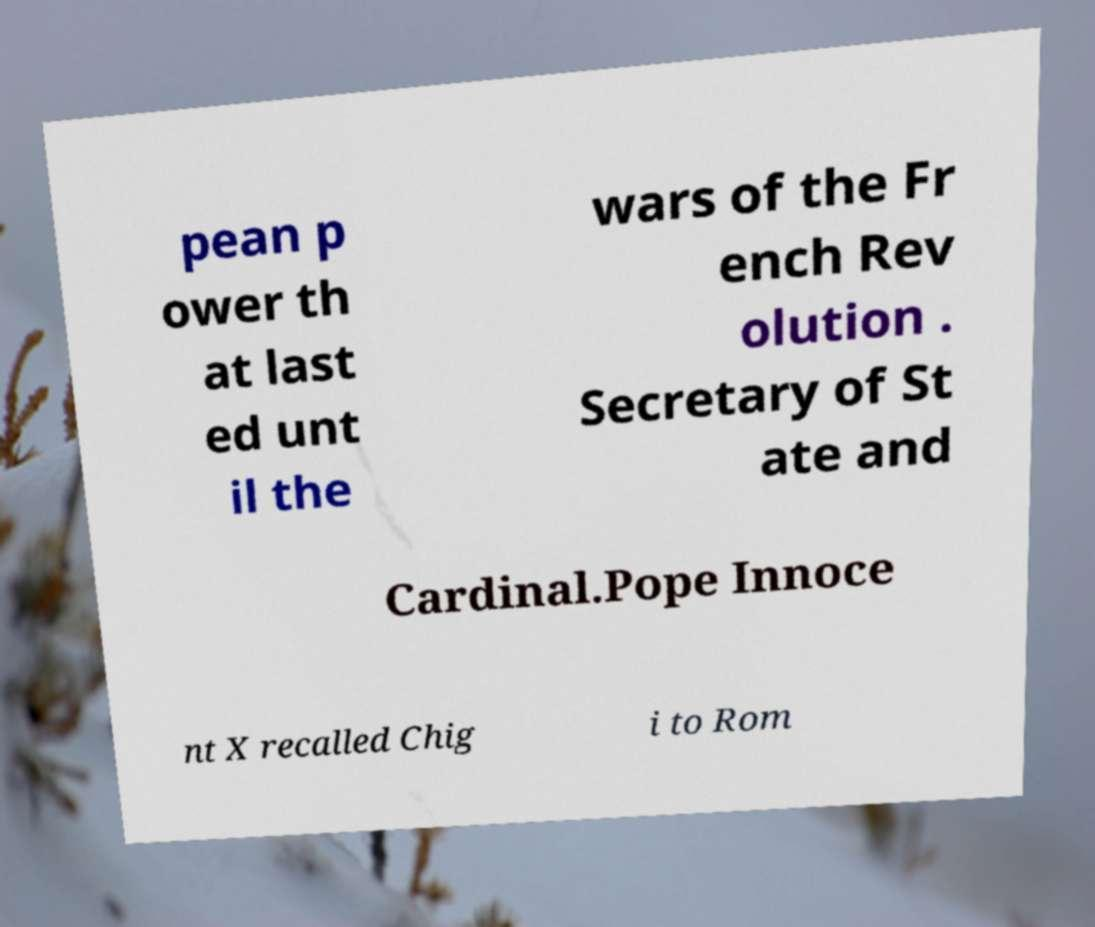Please read and relay the text visible in this image. What does it say? pean p ower th at last ed unt il the wars of the Fr ench Rev olution . Secretary of St ate and Cardinal.Pope Innoce nt X recalled Chig i to Rom 